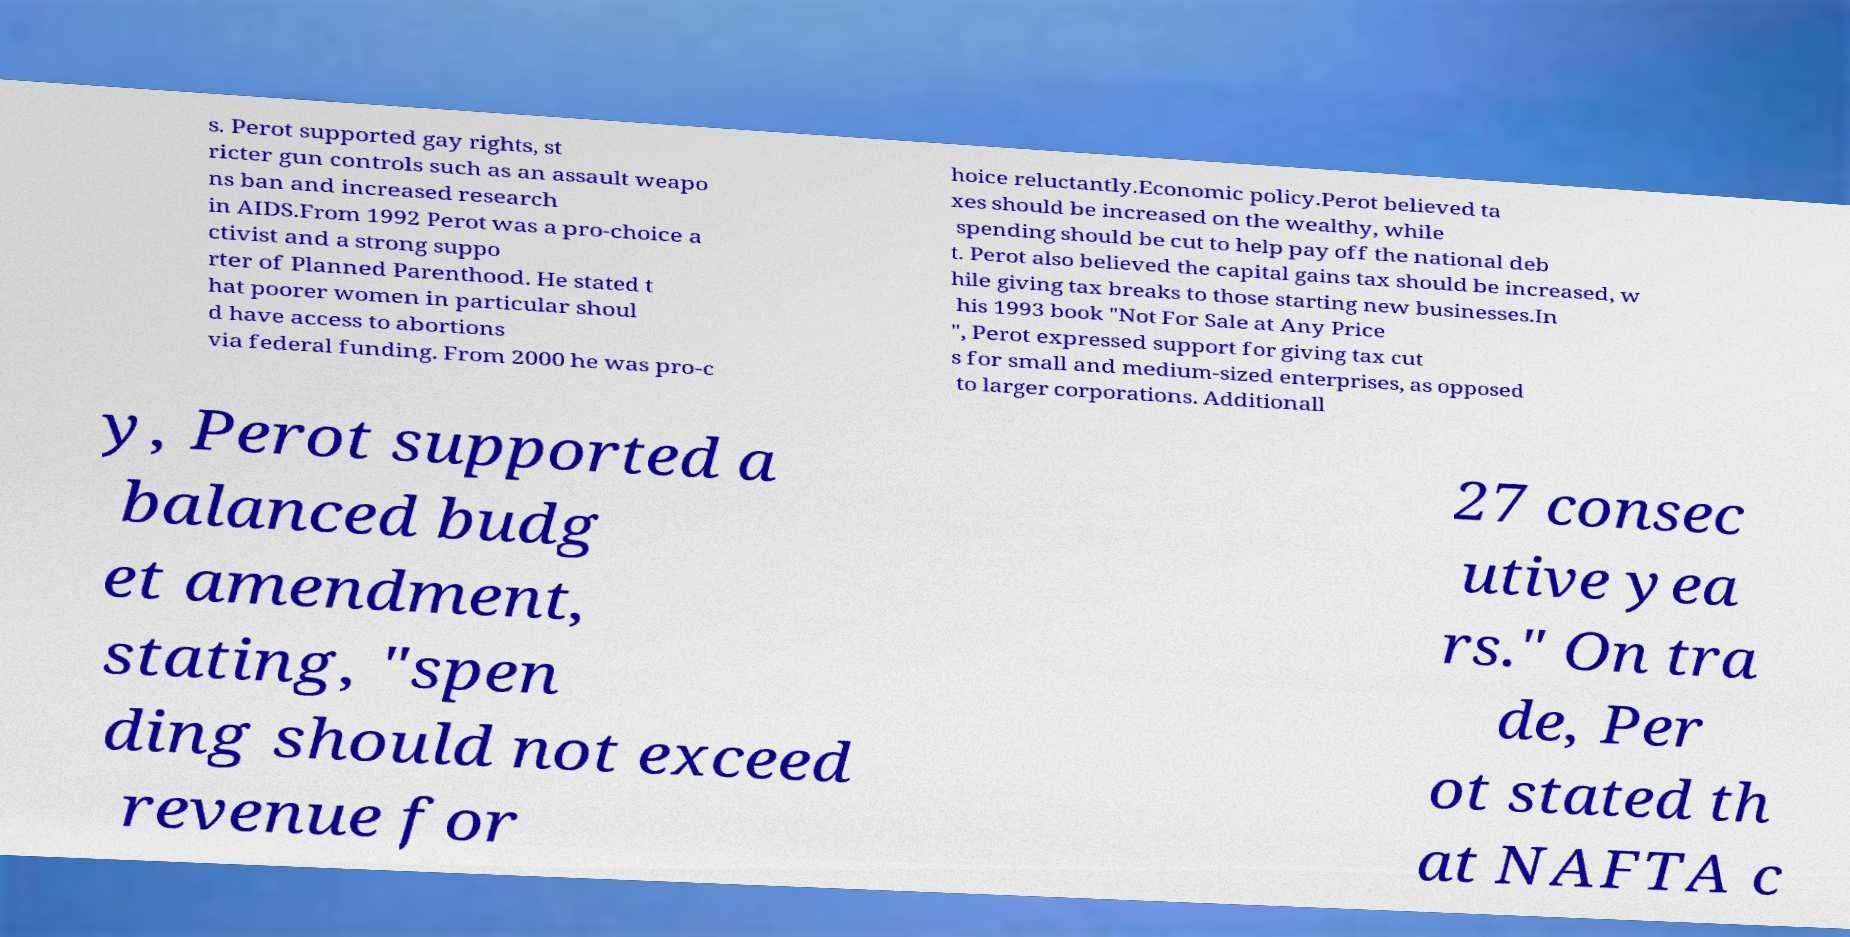What messages or text are displayed in this image? I need them in a readable, typed format. s. Perot supported gay rights, st ricter gun controls such as an assault weapo ns ban and increased research in AIDS.From 1992 Perot was a pro-choice a ctivist and a strong suppo rter of Planned Parenthood. He stated t hat poorer women in particular shoul d have access to abortions via federal funding. From 2000 he was pro-c hoice reluctantly.Economic policy.Perot believed ta xes should be increased on the wealthy, while spending should be cut to help pay off the national deb t. Perot also believed the capital gains tax should be increased, w hile giving tax breaks to those starting new businesses.In his 1993 book "Not For Sale at Any Price ", Perot expressed support for giving tax cut s for small and medium-sized enterprises, as opposed to larger corporations. Additionall y, Perot supported a balanced budg et amendment, stating, "spen ding should not exceed revenue for 27 consec utive yea rs." On tra de, Per ot stated th at NAFTA c 